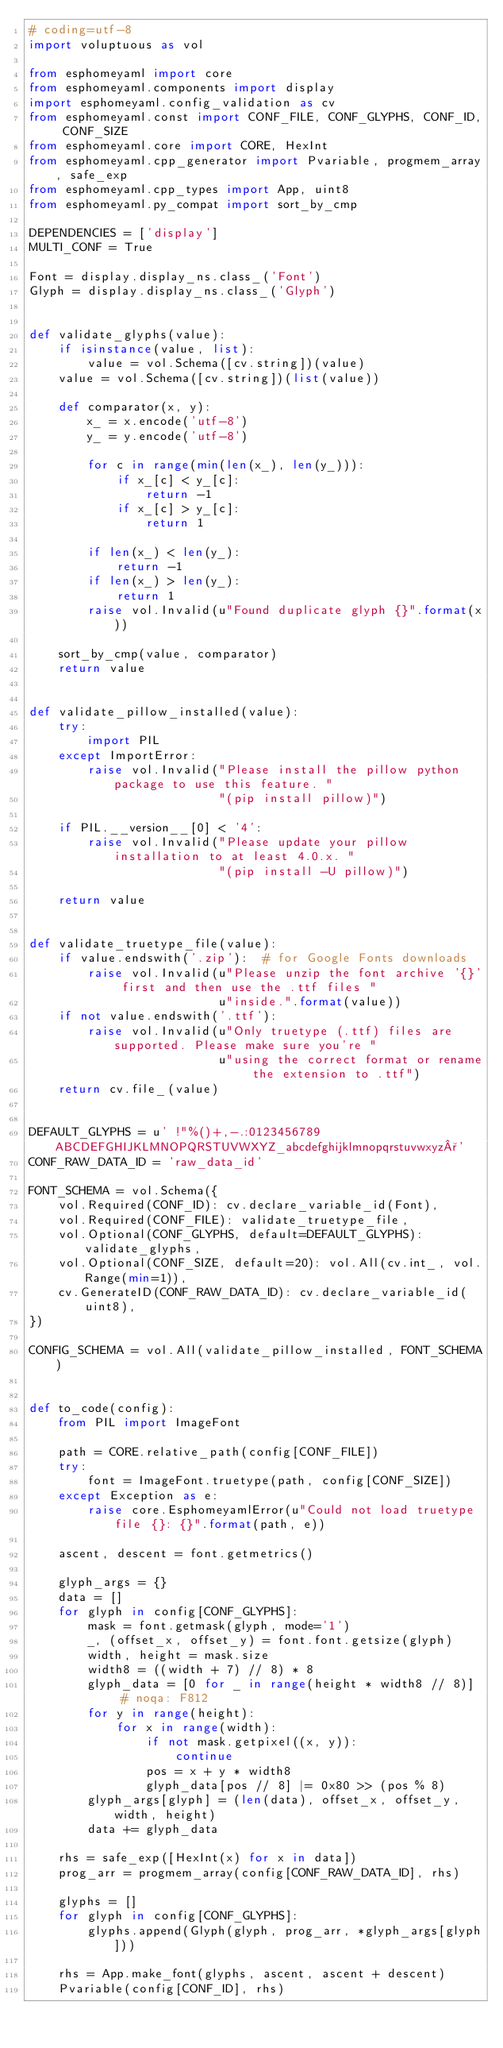Convert code to text. <code><loc_0><loc_0><loc_500><loc_500><_Python_># coding=utf-8
import voluptuous as vol

from esphomeyaml import core
from esphomeyaml.components import display
import esphomeyaml.config_validation as cv
from esphomeyaml.const import CONF_FILE, CONF_GLYPHS, CONF_ID, CONF_SIZE
from esphomeyaml.core import CORE, HexInt
from esphomeyaml.cpp_generator import Pvariable, progmem_array, safe_exp
from esphomeyaml.cpp_types import App, uint8
from esphomeyaml.py_compat import sort_by_cmp

DEPENDENCIES = ['display']
MULTI_CONF = True

Font = display.display_ns.class_('Font')
Glyph = display.display_ns.class_('Glyph')


def validate_glyphs(value):
    if isinstance(value, list):
        value = vol.Schema([cv.string])(value)
    value = vol.Schema([cv.string])(list(value))

    def comparator(x, y):
        x_ = x.encode('utf-8')
        y_ = y.encode('utf-8')

        for c in range(min(len(x_), len(y_))):
            if x_[c] < y_[c]:
                return -1
            if x_[c] > y_[c]:
                return 1

        if len(x_) < len(y_):
            return -1
        if len(x_) > len(y_):
            return 1
        raise vol.Invalid(u"Found duplicate glyph {}".format(x))

    sort_by_cmp(value, comparator)
    return value


def validate_pillow_installed(value):
    try:
        import PIL
    except ImportError:
        raise vol.Invalid("Please install the pillow python package to use this feature. "
                          "(pip install pillow)")

    if PIL.__version__[0] < '4':
        raise vol.Invalid("Please update your pillow installation to at least 4.0.x. "
                          "(pip install -U pillow)")

    return value


def validate_truetype_file(value):
    if value.endswith('.zip'):  # for Google Fonts downloads
        raise vol.Invalid(u"Please unzip the font archive '{}' first and then use the .ttf files "
                          u"inside.".format(value))
    if not value.endswith('.ttf'):
        raise vol.Invalid(u"Only truetype (.ttf) files are supported. Please make sure you're "
                          u"using the correct format or rename the extension to .ttf")
    return cv.file_(value)


DEFAULT_GLYPHS = u' !"%()+,-.:0123456789ABCDEFGHIJKLMNOPQRSTUVWXYZ_abcdefghijklmnopqrstuvwxyz°'
CONF_RAW_DATA_ID = 'raw_data_id'

FONT_SCHEMA = vol.Schema({
    vol.Required(CONF_ID): cv.declare_variable_id(Font),
    vol.Required(CONF_FILE): validate_truetype_file,
    vol.Optional(CONF_GLYPHS, default=DEFAULT_GLYPHS): validate_glyphs,
    vol.Optional(CONF_SIZE, default=20): vol.All(cv.int_, vol.Range(min=1)),
    cv.GenerateID(CONF_RAW_DATA_ID): cv.declare_variable_id(uint8),
})

CONFIG_SCHEMA = vol.All(validate_pillow_installed, FONT_SCHEMA)


def to_code(config):
    from PIL import ImageFont

    path = CORE.relative_path(config[CONF_FILE])
    try:
        font = ImageFont.truetype(path, config[CONF_SIZE])
    except Exception as e:
        raise core.EsphomeyamlError(u"Could not load truetype file {}: {}".format(path, e))

    ascent, descent = font.getmetrics()

    glyph_args = {}
    data = []
    for glyph in config[CONF_GLYPHS]:
        mask = font.getmask(glyph, mode='1')
        _, (offset_x, offset_y) = font.font.getsize(glyph)
        width, height = mask.size
        width8 = ((width + 7) // 8) * 8
        glyph_data = [0 for _ in range(height * width8 // 8)]  # noqa: F812
        for y in range(height):
            for x in range(width):
                if not mask.getpixel((x, y)):
                    continue
                pos = x + y * width8
                glyph_data[pos // 8] |= 0x80 >> (pos % 8)
        glyph_args[glyph] = (len(data), offset_x, offset_y, width, height)
        data += glyph_data

    rhs = safe_exp([HexInt(x) for x in data])
    prog_arr = progmem_array(config[CONF_RAW_DATA_ID], rhs)

    glyphs = []
    for glyph in config[CONF_GLYPHS]:
        glyphs.append(Glyph(glyph, prog_arr, *glyph_args[glyph]))

    rhs = App.make_font(glyphs, ascent, ascent + descent)
    Pvariable(config[CONF_ID], rhs)
</code> 